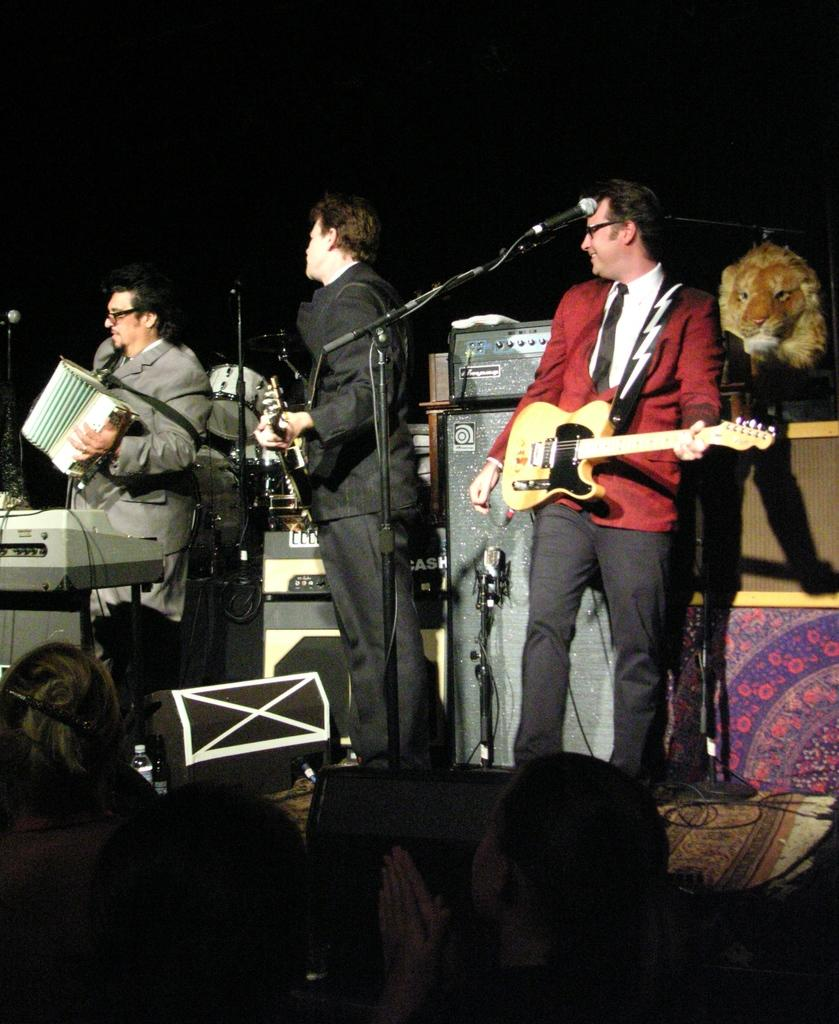How many persons are present in the image? There are three persons in the image. What are the persons in the image doing? They are playing musical instruments. Can you identify any equipment related to their activity? Yes, there is a microphone in the image. What type of produce is being suggested for the next song in the image? There is no produce or suggestion for a next song present in the image. Can you tell me how many pails are visible in the image? There are no pails visible in the image. 